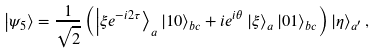<formula> <loc_0><loc_0><loc_500><loc_500>\left | \psi _ { 5 } \right \rangle = \frac { 1 } { \sqrt { 2 } } \left ( \left | \xi e ^ { - i 2 \tau } \right \rangle _ { a } \left | 1 0 \right \rangle _ { b c } + i e ^ { i \theta } \left | \xi \right \rangle _ { a } \left | 0 1 \right \rangle _ { b c } \right ) \left | \eta \right \rangle _ { a ^ { \prime } } ,</formula> 